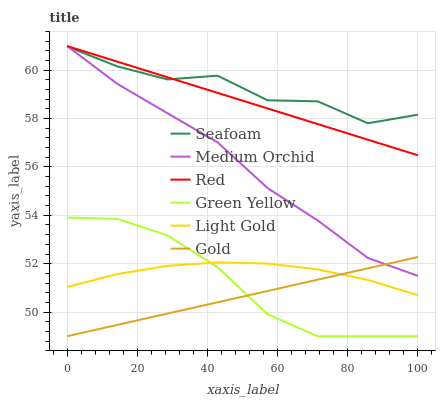Does Gold have the minimum area under the curve?
Answer yes or no. Yes. Does Seafoam have the maximum area under the curve?
Answer yes or no. Yes. Does Medium Orchid have the minimum area under the curve?
Answer yes or no. No. Does Medium Orchid have the maximum area under the curve?
Answer yes or no. No. Is Gold the smoothest?
Answer yes or no. Yes. Is Seafoam the roughest?
Answer yes or no. Yes. Is Medium Orchid the smoothest?
Answer yes or no. No. Is Medium Orchid the roughest?
Answer yes or no. No. Does Medium Orchid have the lowest value?
Answer yes or no. No. Does Red have the highest value?
Answer yes or no. Yes. Does Seafoam have the highest value?
Answer yes or no. No. Is Light Gold less than Medium Orchid?
Answer yes or no. Yes. Is Red greater than Green Yellow?
Answer yes or no. Yes. Does Green Yellow intersect Gold?
Answer yes or no. Yes. Is Green Yellow less than Gold?
Answer yes or no. No. Is Green Yellow greater than Gold?
Answer yes or no. No. Does Light Gold intersect Medium Orchid?
Answer yes or no. No. 